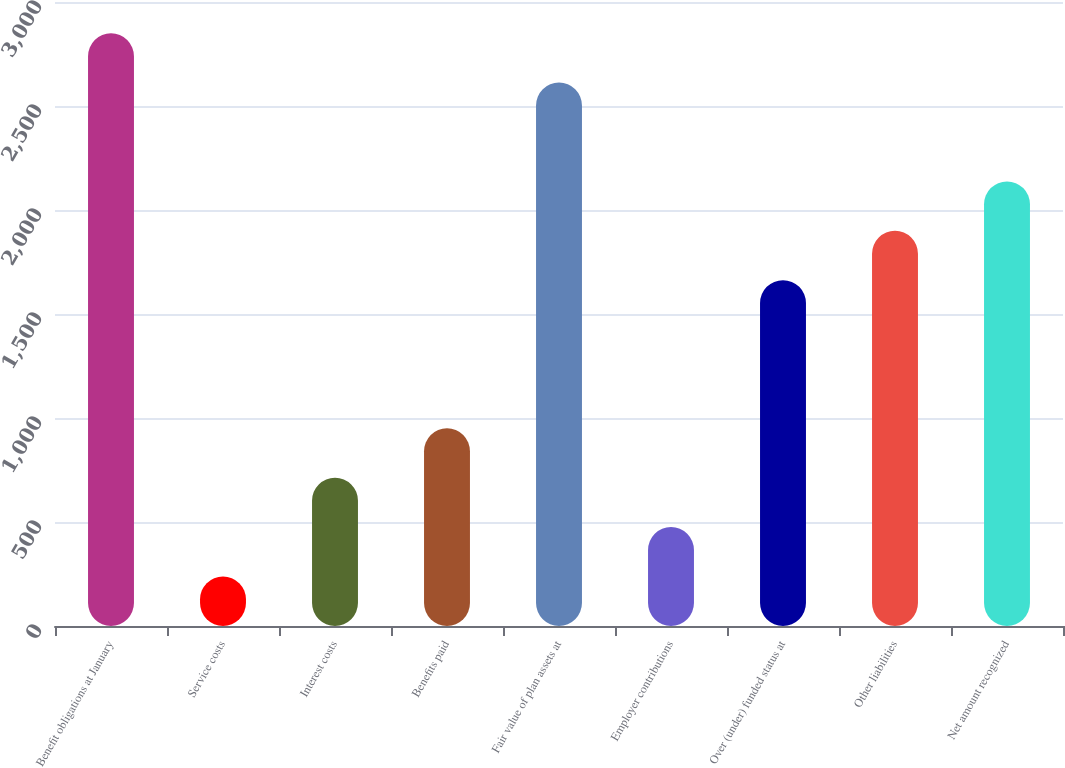<chart> <loc_0><loc_0><loc_500><loc_500><bar_chart><fcel>Benefit obligations at January<fcel>Service costs<fcel>Interest costs<fcel>Benefits paid<fcel>Fair value of plan assets at<fcel>Employer contributions<fcel>Over (under) funded status at<fcel>Other liabilities<fcel>Net amount recognized<nl><fcel>2849.8<fcel>238.4<fcel>713.2<fcel>950.6<fcel>2612.4<fcel>475.8<fcel>1662.8<fcel>1900.2<fcel>2137.6<nl></chart> 